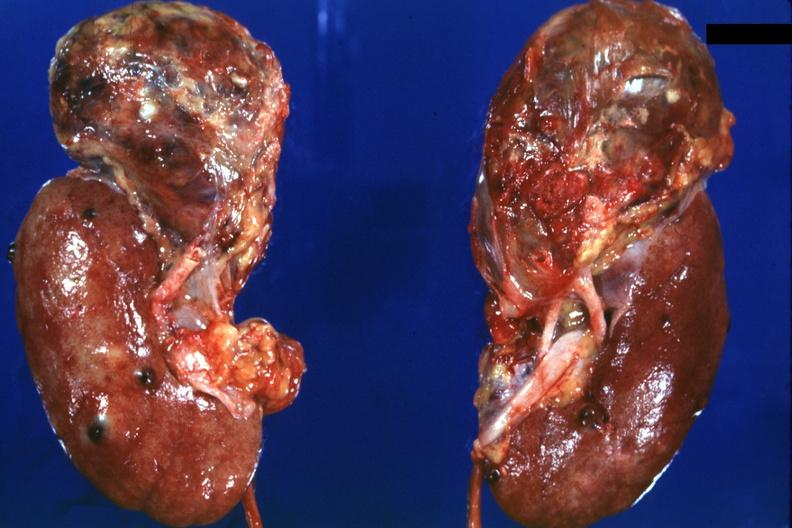s this photo present?
Answer the question using a single word or phrase. No 